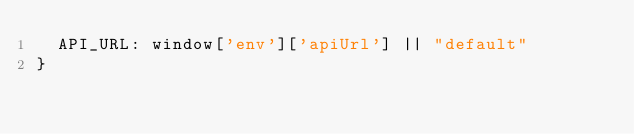<code> <loc_0><loc_0><loc_500><loc_500><_TypeScript_>  API_URL: window['env']['apiUrl'] || "default"
}</code> 